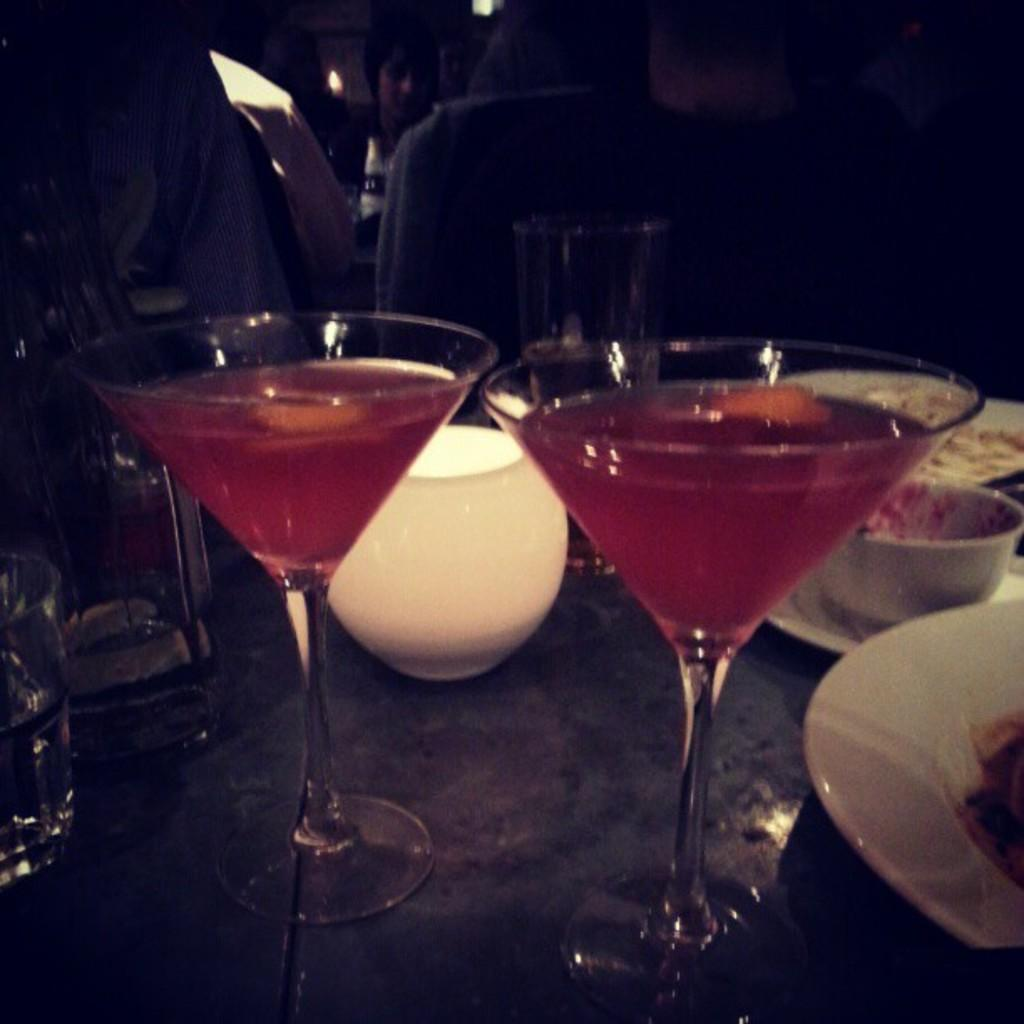What piece of furniture is present in the image? There is a table in the image. What is placed on the table? There is a glass on the table. What is inside the glass? There is liquid in the glass. What type of dishware can be seen in the image? There are bowls and plates in the image. Can you describe the people in the background of the image? There are people sitting on chairs in the background of the image. What type of skirt is being worn by the people in the image? There is no mention of a skirt in the image. 